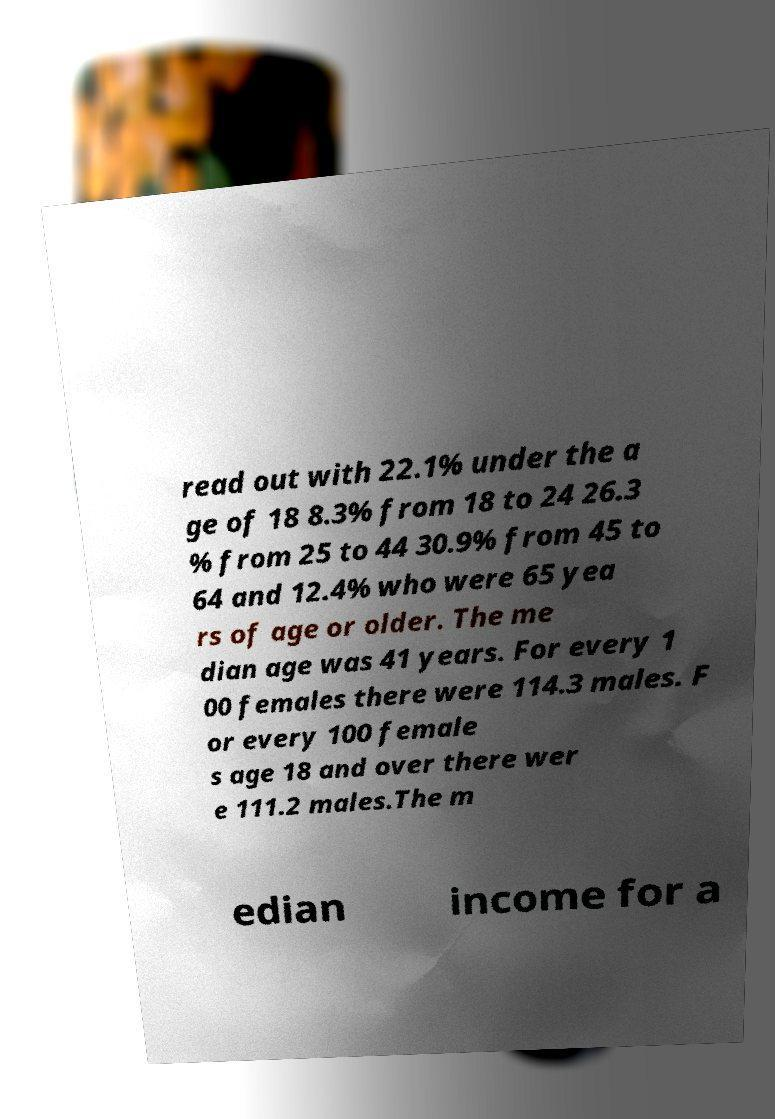There's text embedded in this image that I need extracted. Can you transcribe it verbatim? read out with 22.1% under the a ge of 18 8.3% from 18 to 24 26.3 % from 25 to 44 30.9% from 45 to 64 and 12.4% who were 65 yea rs of age or older. The me dian age was 41 years. For every 1 00 females there were 114.3 males. F or every 100 female s age 18 and over there wer e 111.2 males.The m edian income for a 